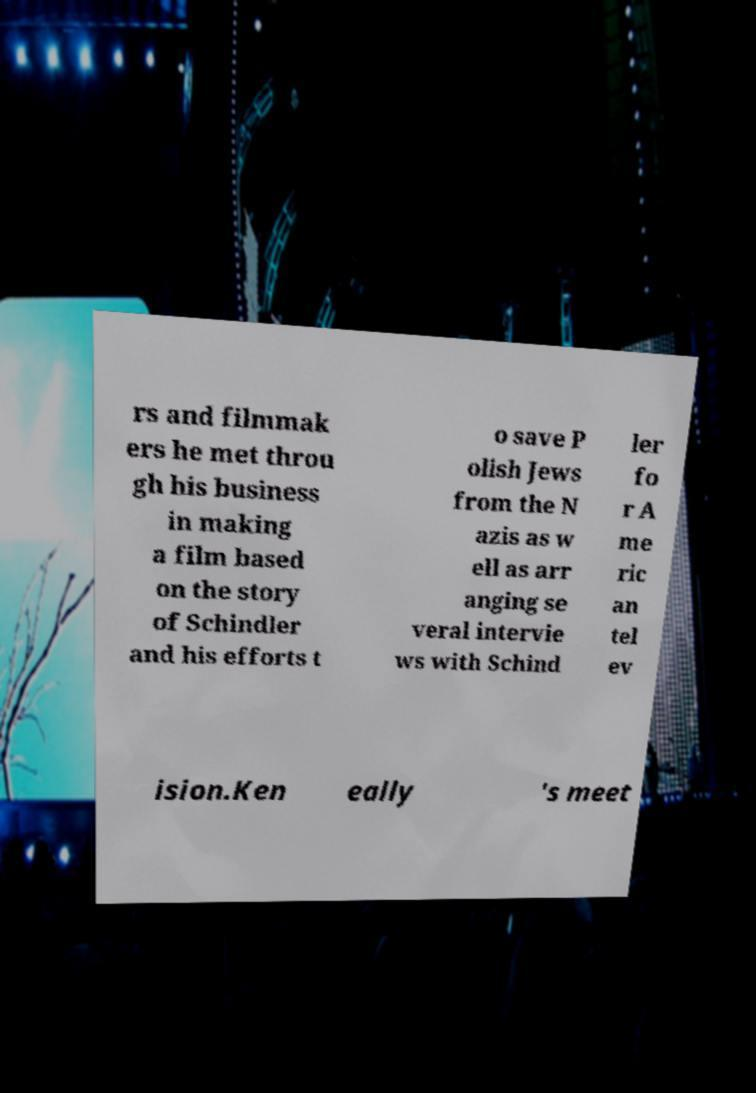I need the written content from this picture converted into text. Can you do that? rs and filmmak ers he met throu gh his business in making a film based on the story of Schindler and his efforts t o save P olish Jews from the N azis as w ell as arr anging se veral intervie ws with Schind ler fo r A me ric an tel ev ision.Ken eally 's meet 